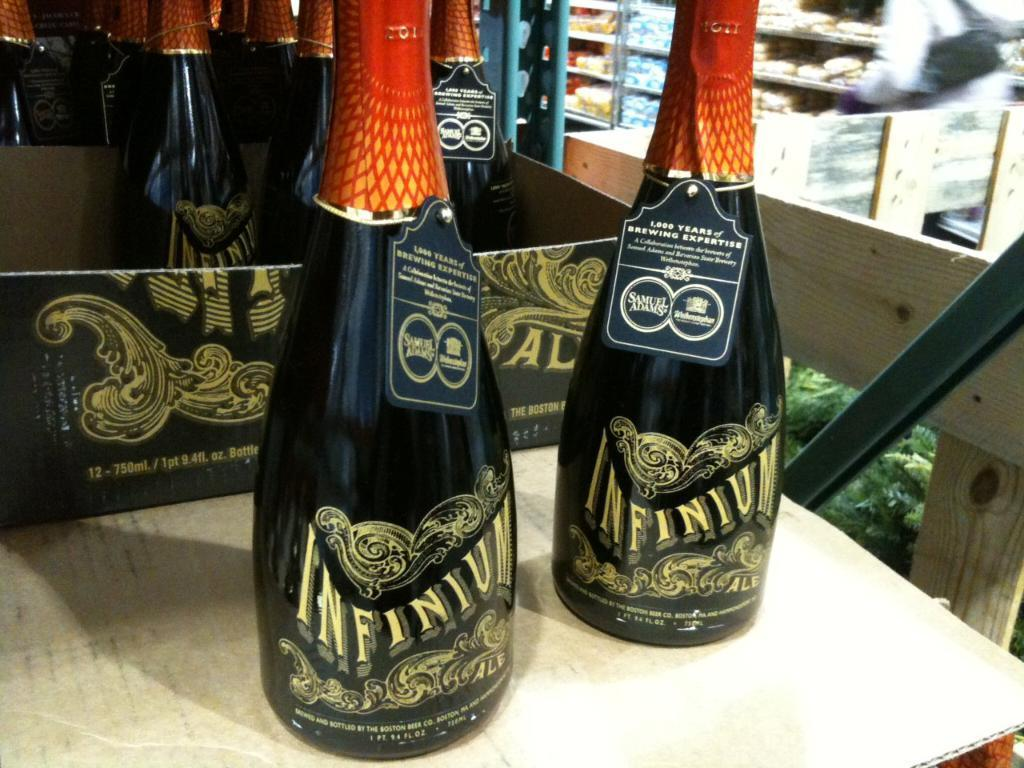<image>
Relay a brief, clear account of the picture shown. Bottles of Infinium featuring 1000 years of brewing expertise. 